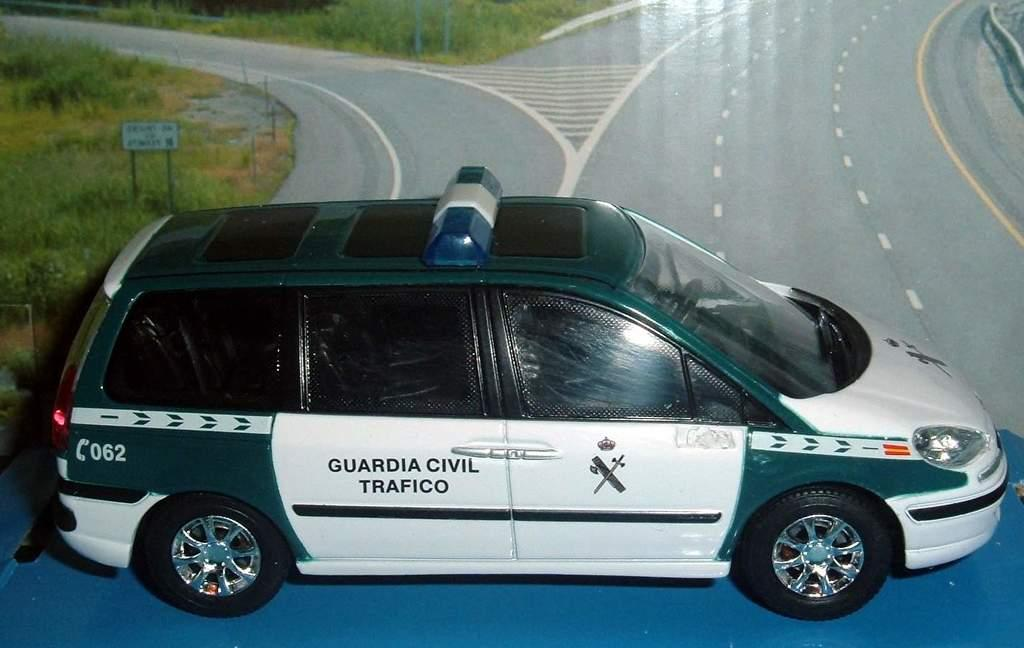<image>
Relay a brief, clear account of the picture shown. A car which has the number 062 on the back left. 